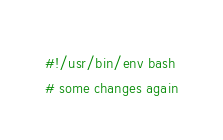<code> <loc_0><loc_0><loc_500><loc_500><_Bash_>#!/usr/bin/env bash
# some changes again
</code> 